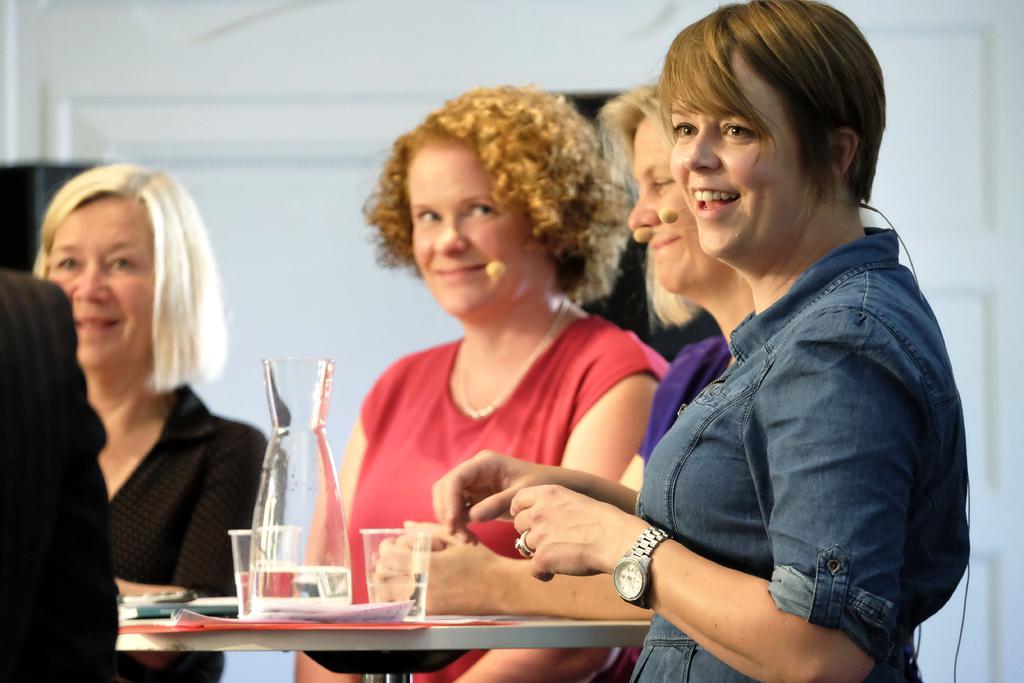Could you give a brief overview of what you see in this image? In this image we can see five people. There are many objects on the table. There is a white color wall in the image. 